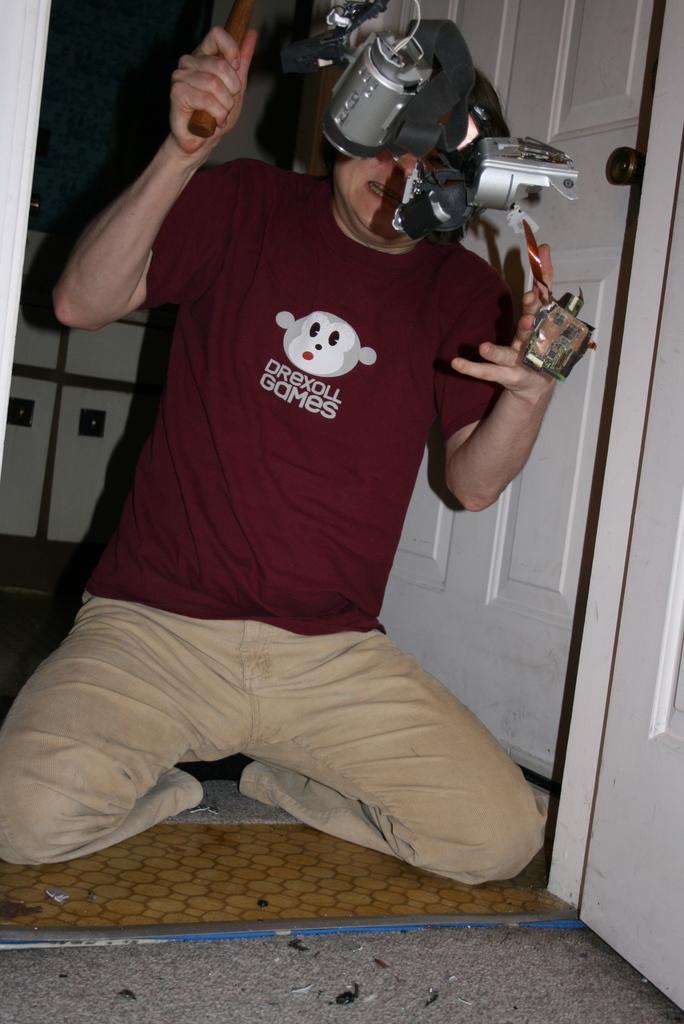Describe this image in one or two sentences. As we can see in the image there is a door, an electrical equipment and a person wearing red color t shirt. 